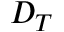Convert formula to latex. <formula><loc_0><loc_0><loc_500><loc_500>D _ { T }</formula> 